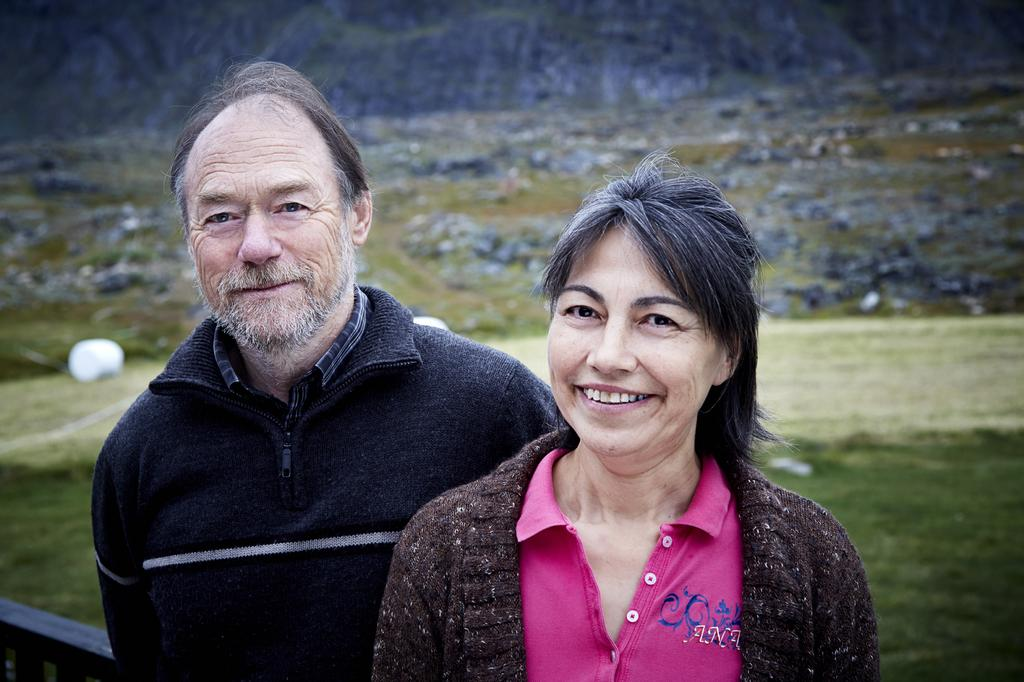Who can be seen in the foreground of the image? There is a man and a woman in the foreground of the image. What expressions do the man and woman have in the image? Both the man and the woman are smiling in the image. What type of natural environment is visible in the background of the image? There is grass, mountains, and stones in the background of the image. Can you describe the unspecified object in the background of the image? Unfortunately, the facts provided do not give enough information to describe the unspecified object in the background. What type of goose can be seen swimming in the harbor in the image? There is no goose or harbor present in the image. What type of copper material is used to create the fence in the image? There is no fence or copper material mentioned in the image. 